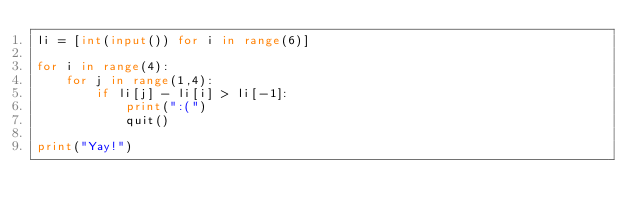Convert code to text. <code><loc_0><loc_0><loc_500><loc_500><_Python_>li = [int(input()) for i in range(6)]

for i in range(4):
    for j in range(1,4):
        if li[j] - li[i] > li[-1]:
            print(":(")
            quit()

print("Yay!")
        
</code> 